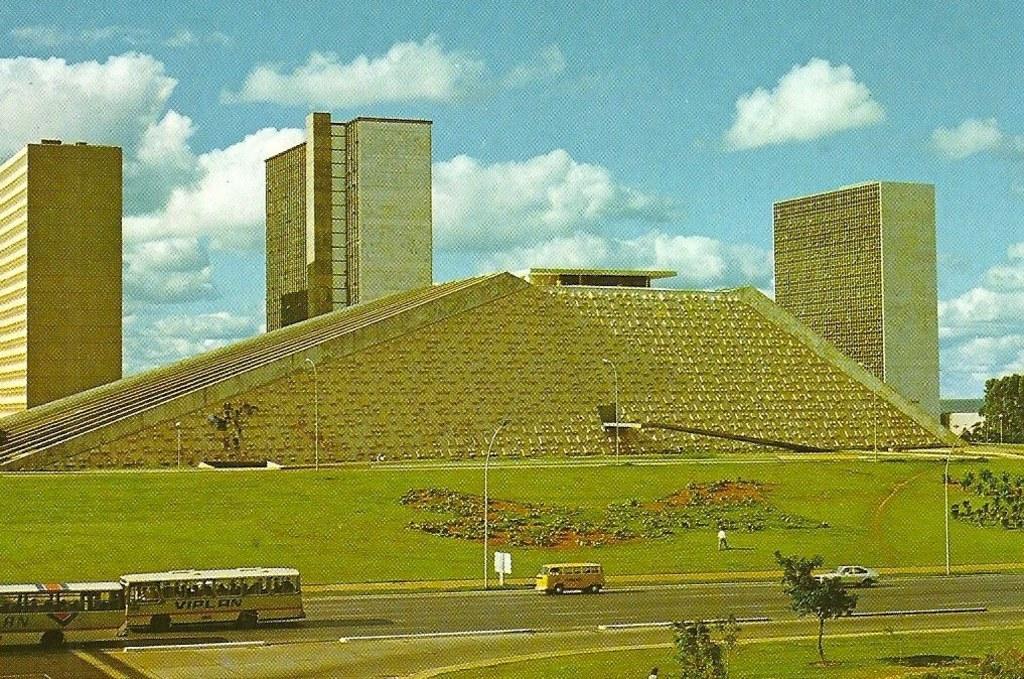Can you describe this image briefly? There are tall buildings and there is a trapezoid like construction and in front of that there is a big garden,beside the garden there is a road and there are some vehicles moving on the road. 